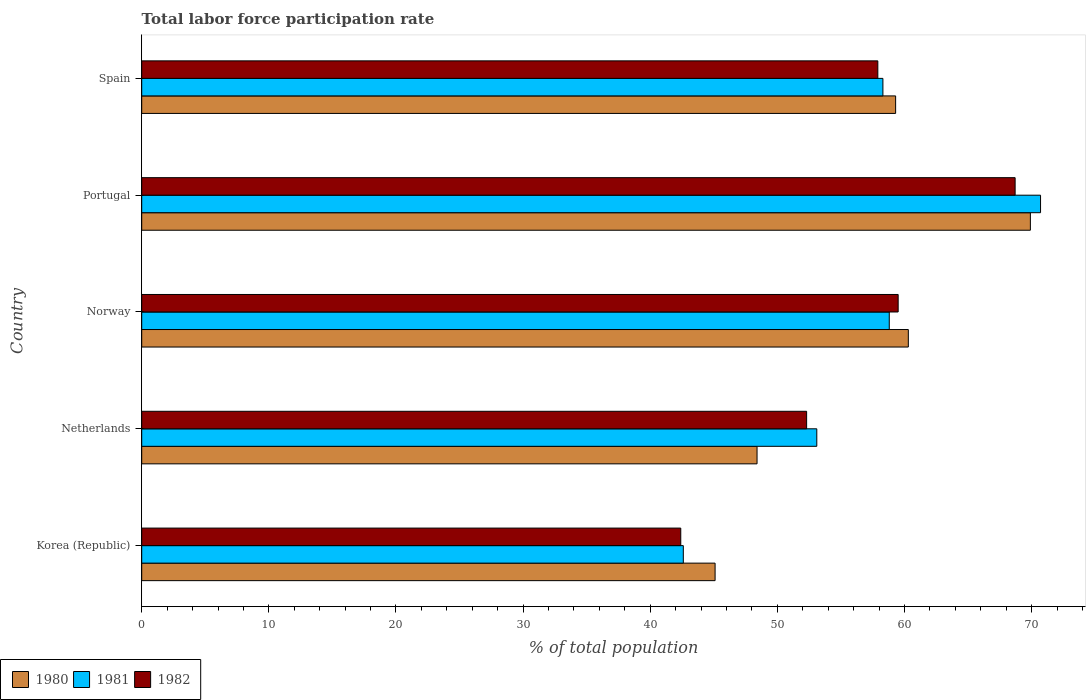How many different coloured bars are there?
Ensure brevity in your answer.  3. Are the number of bars per tick equal to the number of legend labels?
Provide a succinct answer. Yes. Are the number of bars on each tick of the Y-axis equal?
Offer a terse response. Yes. How many bars are there on the 1st tick from the top?
Keep it short and to the point. 3. How many bars are there on the 5th tick from the bottom?
Offer a very short reply. 3. What is the label of the 5th group of bars from the top?
Ensure brevity in your answer.  Korea (Republic). In how many cases, is the number of bars for a given country not equal to the number of legend labels?
Give a very brief answer. 0. What is the total labor force participation rate in 1980 in Norway?
Provide a short and direct response. 60.3. Across all countries, what is the maximum total labor force participation rate in 1982?
Give a very brief answer. 68.7. Across all countries, what is the minimum total labor force participation rate in 1980?
Your answer should be compact. 45.1. What is the total total labor force participation rate in 1982 in the graph?
Offer a terse response. 280.8. What is the difference between the total labor force participation rate in 1982 in Korea (Republic) and that in Spain?
Offer a terse response. -15.5. What is the difference between the total labor force participation rate in 1980 in Spain and the total labor force participation rate in 1982 in Portugal?
Offer a very short reply. -9.4. What is the average total labor force participation rate in 1981 per country?
Give a very brief answer. 56.7. What is the difference between the total labor force participation rate in 1981 and total labor force participation rate in 1980 in Netherlands?
Offer a terse response. 4.7. In how many countries, is the total labor force participation rate in 1982 greater than 6 %?
Offer a terse response. 5. What is the ratio of the total labor force participation rate in 1982 in Korea (Republic) to that in Norway?
Keep it short and to the point. 0.71. Is the total labor force participation rate in 1980 in Portugal less than that in Spain?
Give a very brief answer. No. What is the difference between the highest and the second highest total labor force participation rate in 1980?
Offer a terse response. 9.6. What is the difference between the highest and the lowest total labor force participation rate in 1982?
Provide a succinct answer. 26.3. In how many countries, is the total labor force participation rate in 1980 greater than the average total labor force participation rate in 1980 taken over all countries?
Your answer should be very brief. 3. Is the sum of the total labor force participation rate in 1982 in Korea (Republic) and Portugal greater than the maximum total labor force participation rate in 1980 across all countries?
Ensure brevity in your answer.  Yes. What does the 2nd bar from the top in Norway represents?
Provide a succinct answer. 1981. What does the 1st bar from the bottom in Norway represents?
Your answer should be very brief. 1980. Is it the case that in every country, the sum of the total labor force participation rate in 1981 and total labor force participation rate in 1980 is greater than the total labor force participation rate in 1982?
Offer a terse response. Yes. How many bars are there?
Keep it short and to the point. 15. Are all the bars in the graph horizontal?
Ensure brevity in your answer.  Yes. What is the difference between two consecutive major ticks on the X-axis?
Keep it short and to the point. 10. Are the values on the major ticks of X-axis written in scientific E-notation?
Give a very brief answer. No. How many legend labels are there?
Keep it short and to the point. 3. What is the title of the graph?
Your response must be concise. Total labor force participation rate. What is the label or title of the X-axis?
Your response must be concise. % of total population. What is the % of total population of 1980 in Korea (Republic)?
Make the answer very short. 45.1. What is the % of total population of 1981 in Korea (Republic)?
Keep it short and to the point. 42.6. What is the % of total population of 1982 in Korea (Republic)?
Make the answer very short. 42.4. What is the % of total population of 1980 in Netherlands?
Provide a succinct answer. 48.4. What is the % of total population in 1981 in Netherlands?
Give a very brief answer. 53.1. What is the % of total population of 1982 in Netherlands?
Make the answer very short. 52.3. What is the % of total population of 1980 in Norway?
Give a very brief answer. 60.3. What is the % of total population in 1981 in Norway?
Provide a short and direct response. 58.8. What is the % of total population of 1982 in Norway?
Ensure brevity in your answer.  59.5. What is the % of total population in 1980 in Portugal?
Give a very brief answer. 69.9. What is the % of total population in 1981 in Portugal?
Your answer should be compact. 70.7. What is the % of total population in 1982 in Portugal?
Offer a terse response. 68.7. What is the % of total population in 1980 in Spain?
Keep it short and to the point. 59.3. What is the % of total population in 1981 in Spain?
Ensure brevity in your answer.  58.3. What is the % of total population in 1982 in Spain?
Your response must be concise. 57.9. Across all countries, what is the maximum % of total population in 1980?
Give a very brief answer. 69.9. Across all countries, what is the maximum % of total population in 1981?
Keep it short and to the point. 70.7. Across all countries, what is the maximum % of total population of 1982?
Your answer should be very brief. 68.7. Across all countries, what is the minimum % of total population in 1980?
Provide a succinct answer. 45.1. Across all countries, what is the minimum % of total population of 1981?
Offer a terse response. 42.6. Across all countries, what is the minimum % of total population of 1982?
Ensure brevity in your answer.  42.4. What is the total % of total population of 1980 in the graph?
Your answer should be compact. 283. What is the total % of total population in 1981 in the graph?
Provide a succinct answer. 283.5. What is the total % of total population in 1982 in the graph?
Offer a very short reply. 280.8. What is the difference between the % of total population in 1980 in Korea (Republic) and that in Netherlands?
Keep it short and to the point. -3.3. What is the difference between the % of total population in 1980 in Korea (Republic) and that in Norway?
Your response must be concise. -15.2. What is the difference between the % of total population of 1981 in Korea (Republic) and that in Norway?
Ensure brevity in your answer.  -16.2. What is the difference between the % of total population in 1982 in Korea (Republic) and that in Norway?
Provide a succinct answer. -17.1. What is the difference between the % of total population of 1980 in Korea (Republic) and that in Portugal?
Your response must be concise. -24.8. What is the difference between the % of total population in 1981 in Korea (Republic) and that in Portugal?
Give a very brief answer. -28.1. What is the difference between the % of total population of 1982 in Korea (Republic) and that in Portugal?
Provide a short and direct response. -26.3. What is the difference between the % of total population of 1981 in Korea (Republic) and that in Spain?
Your response must be concise. -15.7. What is the difference between the % of total population of 1982 in Korea (Republic) and that in Spain?
Your answer should be very brief. -15.5. What is the difference between the % of total population of 1981 in Netherlands and that in Norway?
Offer a terse response. -5.7. What is the difference between the % of total population of 1982 in Netherlands and that in Norway?
Your answer should be very brief. -7.2. What is the difference between the % of total population in 1980 in Netherlands and that in Portugal?
Give a very brief answer. -21.5. What is the difference between the % of total population in 1981 in Netherlands and that in Portugal?
Provide a short and direct response. -17.6. What is the difference between the % of total population in 1982 in Netherlands and that in Portugal?
Give a very brief answer. -16.4. What is the difference between the % of total population of 1980 in Netherlands and that in Spain?
Provide a short and direct response. -10.9. What is the difference between the % of total population of 1982 in Netherlands and that in Spain?
Keep it short and to the point. -5.6. What is the difference between the % of total population in 1982 in Norway and that in Portugal?
Offer a terse response. -9.2. What is the difference between the % of total population of 1980 in Portugal and that in Spain?
Offer a terse response. 10.6. What is the difference between the % of total population of 1980 in Korea (Republic) and the % of total population of 1982 in Netherlands?
Your answer should be compact. -7.2. What is the difference between the % of total population in 1980 in Korea (Republic) and the % of total population in 1981 in Norway?
Provide a succinct answer. -13.7. What is the difference between the % of total population in 1980 in Korea (Republic) and the % of total population in 1982 in Norway?
Your answer should be very brief. -14.4. What is the difference between the % of total population in 1981 in Korea (Republic) and the % of total population in 1982 in Norway?
Give a very brief answer. -16.9. What is the difference between the % of total population in 1980 in Korea (Republic) and the % of total population in 1981 in Portugal?
Provide a short and direct response. -25.6. What is the difference between the % of total population of 1980 in Korea (Republic) and the % of total population of 1982 in Portugal?
Your answer should be compact. -23.6. What is the difference between the % of total population in 1981 in Korea (Republic) and the % of total population in 1982 in Portugal?
Keep it short and to the point. -26.1. What is the difference between the % of total population in 1980 in Korea (Republic) and the % of total population in 1981 in Spain?
Ensure brevity in your answer.  -13.2. What is the difference between the % of total population of 1980 in Korea (Republic) and the % of total population of 1982 in Spain?
Provide a succinct answer. -12.8. What is the difference between the % of total population in 1981 in Korea (Republic) and the % of total population in 1982 in Spain?
Offer a very short reply. -15.3. What is the difference between the % of total population of 1981 in Netherlands and the % of total population of 1982 in Norway?
Your answer should be very brief. -6.4. What is the difference between the % of total population of 1980 in Netherlands and the % of total population of 1981 in Portugal?
Your response must be concise. -22.3. What is the difference between the % of total population in 1980 in Netherlands and the % of total population in 1982 in Portugal?
Offer a very short reply. -20.3. What is the difference between the % of total population in 1981 in Netherlands and the % of total population in 1982 in Portugal?
Your response must be concise. -15.6. What is the difference between the % of total population in 1980 in Netherlands and the % of total population in 1981 in Spain?
Provide a short and direct response. -9.9. What is the difference between the % of total population in 1981 in Netherlands and the % of total population in 1982 in Spain?
Your answer should be compact. -4.8. What is the difference between the % of total population of 1980 in Norway and the % of total population of 1981 in Portugal?
Offer a terse response. -10.4. What is the difference between the % of total population of 1980 in Norway and the % of total population of 1982 in Portugal?
Give a very brief answer. -8.4. What is the difference between the % of total population in 1981 in Norway and the % of total population in 1982 in Portugal?
Make the answer very short. -9.9. What is the difference between the % of total population of 1980 in Norway and the % of total population of 1981 in Spain?
Ensure brevity in your answer.  2. What is the difference between the % of total population of 1980 in Norway and the % of total population of 1982 in Spain?
Provide a short and direct response. 2.4. What is the difference between the % of total population of 1981 in Norway and the % of total population of 1982 in Spain?
Provide a succinct answer. 0.9. What is the difference between the % of total population in 1980 in Portugal and the % of total population in 1981 in Spain?
Give a very brief answer. 11.6. What is the average % of total population in 1980 per country?
Ensure brevity in your answer.  56.6. What is the average % of total population of 1981 per country?
Your answer should be compact. 56.7. What is the average % of total population in 1982 per country?
Your answer should be compact. 56.16. What is the difference between the % of total population of 1980 and % of total population of 1982 in Korea (Republic)?
Provide a short and direct response. 2.7. What is the difference between the % of total population in 1981 and % of total population in 1982 in Korea (Republic)?
Offer a very short reply. 0.2. What is the difference between the % of total population of 1980 and % of total population of 1981 in Norway?
Your answer should be very brief. 1.5. What is the difference between the % of total population of 1980 and % of total population of 1982 in Norway?
Ensure brevity in your answer.  0.8. What is the difference between the % of total population in 1980 and % of total population in 1981 in Spain?
Offer a very short reply. 1. What is the ratio of the % of total population of 1980 in Korea (Republic) to that in Netherlands?
Keep it short and to the point. 0.93. What is the ratio of the % of total population of 1981 in Korea (Republic) to that in Netherlands?
Ensure brevity in your answer.  0.8. What is the ratio of the % of total population of 1982 in Korea (Republic) to that in Netherlands?
Provide a short and direct response. 0.81. What is the ratio of the % of total population of 1980 in Korea (Republic) to that in Norway?
Keep it short and to the point. 0.75. What is the ratio of the % of total population in 1981 in Korea (Republic) to that in Norway?
Your answer should be compact. 0.72. What is the ratio of the % of total population of 1982 in Korea (Republic) to that in Norway?
Keep it short and to the point. 0.71. What is the ratio of the % of total population in 1980 in Korea (Republic) to that in Portugal?
Make the answer very short. 0.65. What is the ratio of the % of total population in 1981 in Korea (Republic) to that in Portugal?
Make the answer very short. 0.6. What is the ratio of the % of total population in 1982 in Korea (Republic) to that in Portugal?
Provide a succinct answer. 0.62. What is the ratio of the % of total population in 1980 in Korea (Republic) to that in Spain?
Your answer should be compact. 0.76. What is the ratio of the % of total population of 1981 in Korea (Republic) to that in Spain?
Provide a short and direct response. 0.73. What is the ratio of the % of total population in 1982 in Korea (Republic) to that in Spain?
Your response must be concise. 0.73. What is the ratio of the % of total population of 1980 in Netherlands to that in Norway?
Offer a very short reply. 0.8. What is the ratio of the % of total population in 1981 in Netherlands to that in Norway?
Provide a short and direct response. 0.9. What is the ratio of the % of total population of 1982 in Netherlands to that in Norway?
Ensure brevity in your answer.  0.88. What is the ratio of the % of total population of 1980 in Netherlands to that in Portugal?
Give a very brief answer. 0.69. What is the ratio of the % of total population of 1981 in Netherlands to that in Portugal?
Offer a very short reply. 0.75. What is the ratio of the % of total population in 1982 in Netherlands to that in Portugal?
Ensure brevity in your answer.  0.76. What is the ratio of the % of total population in 1980 in Netherlands to that in Spain?
Keep it short and to the point. 0.82. What is the ratio of the % of total population in 1981 in Netherlands to that in Spain?
Your response must be concise. 0.91. What is the ratio of the % of total population in 1982 in Netherlands to that in Spain?
Keep it short and to the point. 0.9. What is the ratio of the % of total population of 1980 in Norway to that in Portugal?
Provide a succinct answer. 0.86. What is the ratio of the % of total population in 1981 in Norway to that in Portugal?
Offer a very short reply. 0.83. What is the ratio of the % of total population of 1982 in Norway to that in Portugal?
Your response must be concise. 0.87. What is the ratio of the % of total population in 1980 in Norway to that in Spain?
Your answer should be very brief. 1.02. What is the ratio of the % of total population of 1981 in Norway to that in Spain?
Your response must be concise. 1.01. What is the ratio of the % of total population of 1982 in Norway to that in Spain?
Provide a short and direct response. 1.03. What is the ratio of the % of total population in 1980 in Portugal to that in Spain?
Your answer should be very brief. 1.18. What is the ratio of the % of total population of 1981 in Portugal to that in Spain?
Give a very brief answer. 1.21. What is the ratio of the % of total population in 1982 in Portugal to that in Spain?
Offer a very short reply. 1.19. What is the difference between the highest and the second highest % of total population in 1980?
Offer a terse response. 9.6. What is the difference between the highest and the lowest % of total population of 1980?
Ensure brevity in your answer.  24.8. What is the difference between the highest and the lowest % of total population in 1981?
Keep it short and to the point. 28.1. What is the difference between the highest and the lowest % of total population of 1982?
Your answer should be very brief. 26.3. 